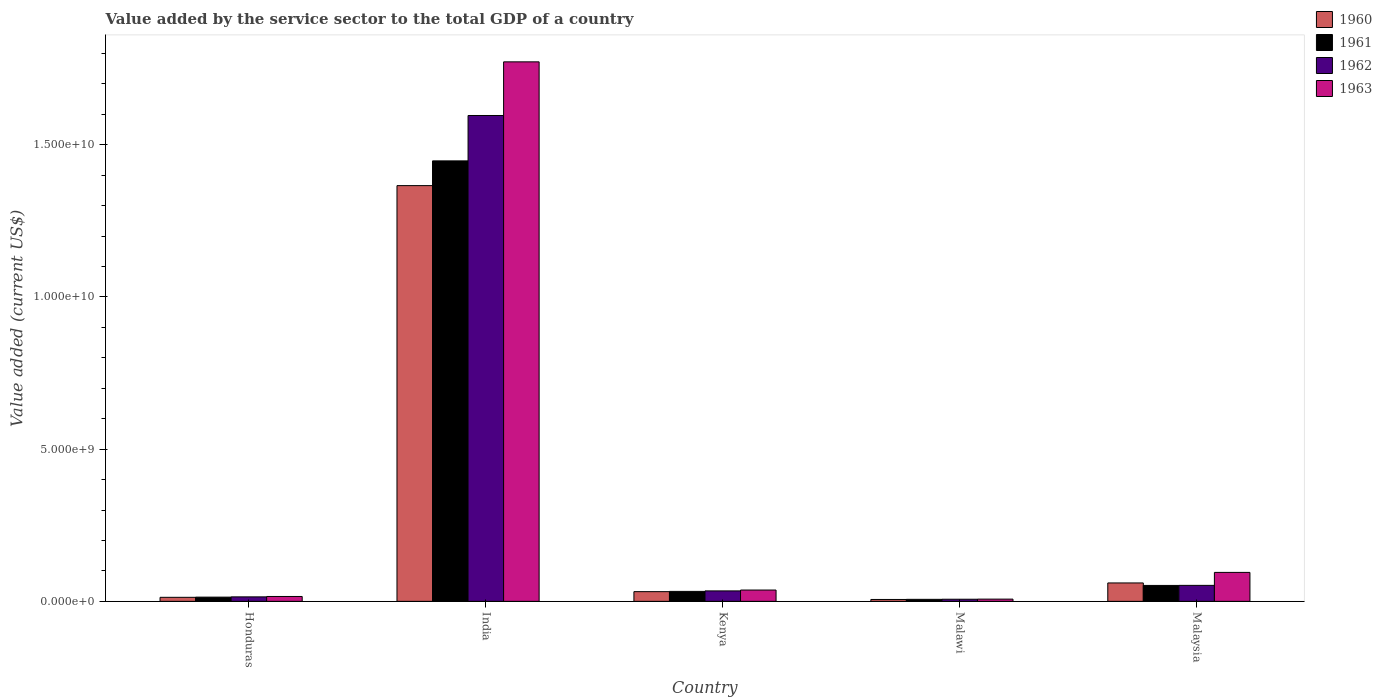Are the number of bars per tick equal to the number of legend labels?
Provide a short and direct response. Yes. Are the number of bars on each tick of the X-axis equal?
Give a very brief answer. Yes. How many bars are there on the 1st tick from the left?
Make the answer very short. 4. How many bars are there on the 2nd tick from the right?
Provide a short and direct response. 4. What is the label of the 5th group of bars from the left?
Give a very brief answer. Malaysia. In how many cases, is the number of bars for a given country not equal to the number of legend labels?
Ensure brevity in your answer.  0. What is the value added by the service sector to the total GDP in 1963 in Honduras?
Provide a short and direct response. 1.60e+08. Across all countries, what is the maximum value added by the service sector to the total GDP in 1962?
Provide a short and direct response. 1.60e+1. Across all countries, what is the minimum value added by the service sector to the total GDP in 1963?
Provide a succinct answer. 7.35e+07. In which country was the value added by the service sector to the total GDP in 1960 minimum?
Your response must be concise. Malawi. What is the total value added by the service sector to the total GDP in 1960 in the graph?
Your answer should be compact. 1.48e+1. What is the difference between the value added by the service sector to the total GDP in 1962 in Malawi and that in Malaysia?
Keep it short and to the point. -4.55e+08. What is the difference between the value added by the service sector to the total GDP in 1963 in Honduras and the value added by the service sector to the total GDP in 1961 in Kenya?
Your response must be concise. -1.67e+08. What is the average value added by the service sector to the total GDP in 1961 per country?
Provide a succinct answer. 3.10e+09. What is the difference between the value added by the service sector to the total GDP of/in 1962 and value added by the service sector to the total GDP of/in 1963 in Honduras?
Your answer should be compact. -1.28e+07. In how many countries, is the value added by the service sector to the total GDP in 1962 greater than 4000000000 US$?
Your response must be concise. 1. What is the ratio of the value added by the service sector to the total GDP in 1962 in India to that in Malaysia?
Ensure brevity in your answer.  30.38. Is the value added by the service sector to the total GDP in 1960 in Honduras less than that in Kenya?
Provide a succinct answer. Yes. Is the difference between the value added by the service sector to the total GDP in 1962 in Honduras and India greater than the difference between the value added by the service sector to the total GDP in 1963 in Honduras and India?
Your answer should be compact. Yes. What is the difference between the highest and the second highest value added by the service sector to the total GDP in 1961?
Make the answer very short. 1.39e+1. What is the difference between the highest and the lowest value added by the service sector to the total GDP in 1961?
Offer a very short reply. 1.44e+1. In how many countries, is the value added by the service sector to the total GDP in 1961 greater than the average value added by the service sector to the total GDP in 1961 taken over all countries?
Keep it short and to the point. 1. What does the 4th bar from the left in Malaysia represents?
Provide a short and direct response. 1963. Is it the case that in every country, the sum of the value added by the service sector to the total GDP in 1962 and value added by the service sector to the total GDP in 1963 is greater than the value added by the service sector to the total GDP in 1960?
Give a very brief answer. Yes. How many bars are there?
Offer a terse response. 20. Are all the bars in the graph horizontal?
Make the answer very short. No. What is the difference between two consecutive major ticks on the Y-axis?
Your answer should be very brief. 5.00e+09. Are the values on the major ticks of Y-axis written in scientific E-notation?
Your answer should be compact. Yes. Does the graph contain any zero values?
Your answer should be very brief. No. Does the graph contain grids?
Your answer should be compact. No. How are the legend labels stacked?
Offer a terse response. Vertical. What is the title of the graph?
Provide a short and direct response. Value added by the service sector to the total GDP of a country. What is the label or title of the Y-axis?
Keep it short and to the point. Value added (current US$). What is the Value added (current US$) in 1960 in Honduras?
Your answer should be very brief. 1.33e+08. What is the Value added (current US$) in 1961 in Honduras?
Offer a very short reply. 1.39e+08. What is the Value added (current US$) of 1962 in Honduras?
Your answer should be very brief. 1.48e+08. What is the Value added (current US$) of 1963 in Honduras?
Provide a short and direct response. 1.60e+08. What is the Value added (current US$) of 1960 in India?
Keep it short and to the point. 1.37e+1. What is the Value added (current US$) of 1961 in India?
Your answer should be compact. 1.45e+1. What is the Value added (current US$) in 1962 in India?
Offer a terse response. 1.60e+1. What is the Value added (current US$) in 1963 in India?
Your answer should be very brief. 1.77e+1. What is the Value added (current US$) of 1960 in Kenya?
Make the answer very short. 3.19e+08. What is the Value added (current US$) of 1961 in Kenya?
Your answer should be very brief. 3.28e+08. What is the Value added (current US$) in 1962 in Kenya?
Offer a very short reply. 3.43e+08. What is the Value added (current US$) in 1963 in Kenya?
Provide a short and direct response. 3.72e+08. What is the Value added (current US$) of 1960 in Malawi?
Provide a succinct answer. 6.24e+07. What is the Value added (current US$) of 1961 in Malawi?
Your answer should be compact. 6.62e+07. What is the Value added (current US$) of 1962 in Malawi?
Make the answer very short. 7.01e+07. What is the Value added (current US$) of 1963 in Malawi?
Make the answer very short. 7.35e+07. What is the Value added (current US$) in 1960 in Malaysia?
Offer a very short reply. 6.05e+08. What is the Value added (current US$) in 1961 in Malaysia?
Your answer should be very brief. 5.23e+08. What is the Value added (current US$) of 1962 in Malaysia?
Keep it short and to the point. 5.25e+08. What is the Value added (current US$) of 1963 in Malaysia?
Make the answer very short. 9.51e+08. Across all countries, what is the maximum Value added (current US$) in 1960?
Offer a terse response. 1.37e+1. Across all countries, what is the maximum Value added (current US$) of 1961?
Offer a very short reply. 1.45e+1. Across all countries, what is the maximum Value added (current US$) of 1962?
Your answer should be compact. 1.60e+1. Across all countries, what is the maximum Value added (current US$) of 1963?
Make the answer very short. 1.77e+1. Across all countries, what is the minimum Value added (current US$) of 1960?
Give a very brief answer. 6.24e+07. Across all countries, what is the minimum Value added (current US$) of 1961?
Make the answer very short. 6.62e+07. Across all countries, what is the minimum Value added (current US$) of 1962?
Ensure brevity in your answer.  7.01e+07. Across all countries, what is the minimum Value added (current US$) in 1963?
Provide a short and direct response. 7.35e+07. What is the total Value added (current US$) in 1960 in the graph?
Offer a very short reply. 1.48e+1. What is the total Value added (current US$) in 1961 in the graph?
Ensure brevity in your answer.  1.55e+1. What is the total Value added (current US$) of 1962 in the graph?
Ensure brevity in your answer.  1.70e+1. What is the total Value added (current US$) of 1963 in the graph?
Offer a terse response. 1.93e+1. What is the difference between the Value added (current US$) in 1960 in Honduras and that in India?
Your response must be concise. -1.35e+1. What is the difference between the Value added (current US$) of 1961 in Honduras and that in India?
Give a very brief answer. -1.43e+1. What is the difference between the Value added (current US$) of 1962 in Honduras and that in India?
Ensure brevity in your answer.  -1.58e+1. What is the difference between the Value added (current US$) in 1963 in Honduras and that in India?
Provide a short and direct response. -1.76e+1. What is the difference between the Value added (current US$) in 1960 in Honduras and that in Kenya?
Offer a very short reply. -1.86e+08. What is the difference between the Value added (current US$) of 1961 in Honduras and that in Kenya?
Provide a succinct answer. -1.89e+08. What is the difference between the Value added (current US$) in 1962 in Honduras and that in Kenya?
Make the answer very short. -1.96e+08. What is the difference between the Value added (current US$) in 1963 in Honduras and that in Kenya?
Give a very brief answer. -2.11e+08. What is the difference between the Value added (current US$) of 1960 in Honduras and that in Malawi?
Provide a succinct answer. 7.02e+07. What is the difference between the Value added (current US$) of 1961 in Honduras and that in Malawi?
Your answer should be compact. 7.25e+07. What is the difference between the Value added (current US$) of 1962 in Honduras and that in Malawi?
Offer a terse response. 7.75e+07. What is the difference between the Value added (current US$) in 1963 in Honduras and that in Malawi?
Ensure brevity in your answer.  8.69e+07. What is the difference between the Value added (current US$) of 1960 in Honduras and that in Malaysia?
Your answer should be very brief. -4.72e+08. What is the difference between the Value added (current US$) in 1961 in Honduras and that in Malaysia?
Make the answer very short. -3.85e+08. What is the difference between the Value added (current US$) in 1962 in Honduras and that in Malaysia?
Give a very brief answer. -3.78e+08. What is the difference between the Value added (current US$) of 1963 in Honduras and that in Malaysia?
Offer a very short reply. -7.91e+08. What is the difference between the Value added (current US$) in 1960 in India and that in Kenya?
Your response must be concise. 1.33e+1. What is the difference between the Value added (current US$) in 1961 in India and that in Kenya?
Offer a terse response. 1.41e+1. What is the difference between the Value added (current US$) of 1962 in India and that in Kenya?
Provide a succinct answer. 1.56e+1. What is the difference between the Value added (current US$) of 1963 in India and that in Kenya?
Ensure brevity in your answer.  1.73e+1. What is the difference between the Value added (current US$) in 1960 in India and that in Malawi?
Offer a very short reply. 1.36e+1. What is the difference between the Value added (current US$) of 1961 in India and that in Malawi?
Offer a very short reply. 1.44e+1. What is the difference between the Value added (current US$) of 1962 in India and that in Malawi?
Your answer should be very brief. 1.59e+1. What is the difference between the Value added (current US$) in 1963 in India and that in Malawi?
Offer a terse response. 1.76e+1. What is the difference between the Value added (current US$) of 1960 in India and that in Malaysia?
Give a very brief answer. 1.31e+1. What is the difference between the Value added (current US$) of 1961 in India and that in Malaysia?
Provide a short and direct response. 1.39e+1. What is the difference between the Value added (current US$) of 1962 in India and that in Malaysia?
Offer a terse response. 1.54e+1. What is the difference between the Value added (current US$) in 1963 in India and that in Malaysia?
Keep it short and to the point. 1.68e+1. What is the difference between the Value added (current US$) in 1960 in Kenya and that in Malawi?
Make the answer very short. 2.57e+08. What is the difference between the Value added (current US$) of 1961 in Kenya and that in Malawi?
Your response must be concise. 2.62e+08. What is the difference between the Value added (current US$) in 1962 in Kenya and that in Malawi?
Provide a short and direct response. 2.73e+08. What is the difference between the Value added (current US$) of 1963 in Kenya and that in Malawi?
Offer a terse response. 2.98e+08. What is the difference between the Value added (current US$) in 1960 in Kenya and that in Malaysia?
Keep it short and to the point. -2.86e+08. What is the difference between the Value added (current US$) in 1961 in Kenya and that in Malaysia?
Your response must be concise. -1.96e+08. What is the difference between the Value added (current US$) in 1962 in Kenya and that in Malaysia?
Keep it short and to the point. -1.82e+08. What is the difference between the Value added (current US$) of 1963 in Kenya and that in Malaysia?
Give a very brief answer. -5.79e+08. What is the difference between the Value added (current US$) in 1960 in Malawi and that in Malaysia?
Provide a short and direct response. -5.43e+08. What is the difference between the Value added (current US$) in 1961 in Malawi and that in Malaysia?
Offer a terse response. -4.57e+08. What is the difference between the Value added (current US$) of 1962 in Malawi and that in Malaysia?
Offer a terse response. -4.55e+08. What is the difference between the Value added (current US$) of 1963 in Malawi and that in Malaysia?
Offer a terse response. -8.78e+08. What is the difference between the Value added (current US$) of 1960 in Honduras and the Value added (current US$) of 1961 in India?
Your answer should be very brief. -1.43e+1. What is the difference between the Value added (current US$) of 1960 in Honduras and the Value added (current US$) of 1962 in India?
Your answer should be compact. -1.58e+1. What is the difference between the Value added (current US$) in 1960 in Honduras and the Value added (current US$) in 1963 in India?
Keep it short and to the point. -1.76e+1. What is the difference between the Value added (current US$) of 1961 in Honduras and the Value added (current US$) of 1962 in India?
Offer a very short reply. -1.58e+1. What is the difference between the Value added (current US$) of 1961 in Honduras and the Value added (current US$) of 1963 in India?
Your response must be concise. -1.76e+1. What is the difference between the Value added (current US$) of 1962 in Honduras and the Value added (current US$) of 1963 in India?
Your answer should be very brief. -1.76e+1. What is the difference between the Value added (current US$) of 1960 in Honduras and the Value added (current US$) of 1961 in Kenya?
Your answer should be compact. -1.95e+08. What is the difference between the Value added (current US$) in 1960 in Honduras and the Value added (current US$) in 1962 in Kenya?
Keep it short and to the point. -2.11e+08. What is the difference between the Value added (current US$) in 1960 in Honduras and the Value added (current US$) in 1963 in Kenya?
Make the answer very short. -2.39e+08. What is the difference between the Value added (current US$) of 1961 in Honduras and the Value added (current US$) of 1962 in Kenya?
Ensure brevity in your answer.  -2.05e+08. What is the difference between the Value added (current US$) of 1961 in Honduras and the Value added (current US$) of 1963 in Kenya?
Your answer should be compact. -2.33e+08. What is the difference between the Value added (current US$) of 1962 in Honduras and the Value added (current US$) of 1963 in Kenya?
Keep it short and to the point. -2.24e+08. What is the difference between the Value added (current US$) in 1960 in Honduras and the Value added (current US$) in 1961 in Malawi?
Your answer should be compact. 6.64e+07. What is the difference between the Value added (current US$) of 1960 in Honduras and the Value added (current US$) of 1962 in Malawi?
Provide a short and direct response. 6.25e+07. What is the difference between the Value added (current US$) of 1960 in Honduras and the Value added (current US$) of 1963 in Malawi?
Make the answer very short. 5.91e+07. What is the difference between the Value added (current US$) in 1961 in Honduras and the Value added (current US$) in 1962 in Malawi?
Offer a very short reply. 6.86e+07. What is the difference between the Value added (current US$) in 1961 in Honduras and the Value added (current US$) in 1963 in Malawi?
Give a very brief answer. 6.52e+07. What is the difference between the Value added (current US$) in 1962 in Honduras and the Value added (current US$) in 1963 in Malawi?
Your answer should be very brief. 7.41e+07. What is the difference between the Value added (current US$) in 1960 in Honduras and the Value added (current US$) in 1961 in Malaysia?
Provide a short and direct response. -3.91e+08. What is the difference between the Value added (current US$) of 1960 in Honduras and the Value added (current US$) of 1962 in Malaysia?
Make the answer very short. -3.93e+08. What is the difference between the Value added (current US$) in 1960 in Honduras and the Value added (current US$) in 1963 in Malaysia?
Provide a succinct answer. -8.18e+08. What is the difference between the Value added (current US$) in 1961 in Honduras and the Value added (current US$) in 1962 in Malaysia?
Give a very brief answer. -3.87e+08. What is the difference between the Value added (current US$) in 1961 in Honduras and the Value added (current US$) in 1963 in Malaysia?
Make the answer very short. -8.12e+08. What is the difference between the Value added (current US$) in 1962 in Honduras and the Value added (current US$) in 1963 in Malaysia?
Your answer should be compact. -8.03e+08. What is the difference between the Value added (current US$) in 1960 in India and the Value added (current US$) in 1961 in Kenya?
Your response must be concise. 1.33e+1. What is the difference between the Value added (current US$) of 1960 in India and the Value added (current US$) of 1962 in Kenya?
Offer a terse response. 1.33e+1. What is the difference between the Value added (current US$) in 1960 in India and the Value added (current US$) in 1963 in Kenya?
Your answer should be compact. 1.33e+1. What is the difference between the Value added (current US$) in 1961 in India and the Value added (current US$) in 1962 in Kenya?
Provide a short and direct response. 1.41e+1. What is the difference between the Value added (current US$) in 1961 in India and the Value added (current US$) in 1963 in Kenya?
Make the answer very short. 1.41e+1. What is the difference between the Value added (current US$) in 1962 in India and the Value added (current US$) in 1963 in Kenya?
Make the answer very short. 1.56e+1. What is the difference between the Value added (current US$) in 1960 in India and the Value added (current US$) in 1961 in Malawi?
Keep it short and to the point. 1.36e+1. What is the difference between the Value added (current US$) of 1960 in India and the Value added (current US$) of 1962 in Malawi?
Your answer should be very brief. 1.36e+1. What is the difference between the Value added (current US$) in 1960 in India and the Value added (current US$) in 1963 in Malawi?
Ensure brevity in your answer.  1.36e+1. What is the difference between the Value added (current US$) in 1961 in India and the Value added (current US$) in 1962 in Malawi?
Provide a short and direct response. 1.44e+1. What is the difference between the Value added (current US$) of 1961 in India and the Value added (current US$) of 1963 in Malawi?
Provide a short and direct response. 1.44e+1. What is the difference between the Value added (current US$) of 1962 in India and the Value added (current US$) of 1963 in Malawi?
Ensure brevity in your answer.  1.59e+1. What is the difference between the Value added (current US$) of 1960 in India and the Value added (current US$) of 1961 in Malaysia?
Give a very brief answer. 1.31e+1. What is the difference between the Value added (current US$) in 1960 in India and the Value added (current US$) in 1962 in Malaysia?
Offer a terse response. 1.31e+1. What is the difference between the Value added (current US$) in 1960 in India and the Value added (current US$) in 1963 in Malaysia?
Provide a short and direct response. 1.27e+1. What is the difference between the Value added (current US$) of 1961 in India and the Value added (current US$) of 1962 in Malaysia?
Keep it short and to the point. 1.39e+1. What is the difference between the Value added (current US$) in 1961 in India and the Value added (current US$) in 1963 in Malaysia?
Your answer should be very brief. 1.35e+1. What is the difference between the Value added (current US$) in 1962 in India and the Value added (current US$) in 1963 in Malaysia?
Make the answer very short. 1.50e+1. What is the difference between the Value added (current US$) of 1960 in Kenya and the Value added (current US$) of 1961 in Malawi?
Provide a short and direct response. 2.53e+08. What is the difference between the Value added (current US$) in 1960 in Kenya and the Value added (current US$) in 1962 in Malawi?
Keep it short and to the point. 2.49e+08. What is the difference between the Value added (current US$) in 1960 in Kenya and the Value added (current US$) in 1963 in Malawi?
Your response must be concise. 2.46e+08. What is the difference between the Value added (current US$) in 1961 in Kenya and the Value added (current US$) in 1962 in Malawi?
Provide a short and direct response. 2.58e+08. What is the difference between the Value added (current US$) of 1961 in Kenya and the Value added (current US$) of 1963 in Malawi?
Offer a very short reply. 2.54e+08. What is the difference between the Value added (current US$) of 1962 in Kenya and the Value added (current US$) of 1963 in Malawi?
Provide a succinct answer. 2.70e+08. What is the difference between the Value added (current US$) of 1960 in Kenya and the Value added (current US$) of 1961 in Malaysia?
Provide a short and direct response. -2.04e+08. What is the difference between the Value added (current US$) in 1960 in Kenya and the Value added (current US$) in 1962 in Malaysia?
Provide a short and direct response. -2.06e+08. What is the difference between the Value added (current US$) in 1960 in Kenya and the Value added (current US$) in 1963 in Malaysia?
Provide a succinct answer. -6.32e+08. What is the difference between the Value added (current US$) in 1961 in Kenya and the Value added (current US$) in 1962 in Malaysia?
Offer a terse response. -1.98e+08. What is the difference between the Value added (current US$) in 1961 in Kenya and the Value added (current US$) in 1963 in Malaysia?
Keep it short and to the point. -6.23e+08. What is the difference between the Value added (current US$) in 1962 in Kenya and the Value added (current US$) in 1963 in Malaysia?
Make the answer very short. -6.08e+08. What is the difference between the Value added (current US$) of 1960 in Malawi and the Value added (current US$) of 1961 in Malaysia?
Make the answer very short. -4.61e+08. What is the difference between the Value added (current US$) in 1960 in Malawi and the Value added (current US$) in 1962 in Malaysia?
Provide a short and direct response. -4.63e+08. What is the difference between the Value added (current US$) of 1960 in Malawi and the Value added (current US$) of 1963 in Malaysia?
Give a very brief answer. -8.89e+08. What is the difference between the Value added (current US$) in 1961 in Malawi and the Value added (current US$) in 1962 in Malaysia?
Offer a terse response. -4.59e+08. What is the difference between the Value added (current US$) of 1961 in Malawi and the Value added (current US$) of 1963 in Malaysia?
Your answer should be compact. -8.85e+08. What is the difference between the Value added (current US$) in 1962 in Malawi and the Value added (current US$) in 1963 in Malaysia?
Your answer should be very brief. -8.81e+08. What is the average Value added (current US$) of 1960 per country?
Make the answer very short. 2.95e+09. What is the average Value added (current US$) of 1961 per country?
Offer a terse response. 3.10e+09. What is the average Value added (current US$) of 1962 per country?
Give a very brief answer. 3.41e+09. What is the average Value added (current US$) of 1963 per country?
Provide a short and direct response. 3.86e+09. What is the difference between the Value added (current US$) of 1960 and Value added (current US$) of 1961 in Honduras?
Provide a succinct answer. -6.15e+06. What is the difference between the Value added (current US$) of 1960 and Value added (current US$) of 1962 in Honduras?
Your response must be concise. -1.50e+07. What is the difference between the Value added (current US$) in 1960 and Value added (current US$) in 1963 in Honduras?
Give a very brief answer. -2.78e+07. What is the difference between the Value added (current US$) of 1961 and Value added (current US$) of 1962 in Honduras?
Your answer should be compact. -8.90e+06. What is the difference between the Value added (current US$) of 1961 and Value added (current US$) of 1963 in Honduras?
Give a very brief answer. -2.17e+07. What is the difference between the Value added (current US$) in 1962 and Value added (current US$) in 1963 in Honduras?
Ensure brevity in your answer.  -1.28e+07. What is the difference between the Value added (current US$) of 1960 and Value added (current US$) of 1961 in India?
Offer a very short reply. -8.13e+08. What is the difference between the Value added (current US$) of 1960 and Value added (current US$) of 1962 in India?
Your response must be concise. -2.30e+09. What is the difference between the Value added (current US$) in 1960 and Value added (current US$) in 1963 in India?
Provide a succinct answer. -4.07e+09. What is the difference between the Value added (current US$) in 1961 and Value added (current US$) in 1962 in India?
Offer a terse response. -1.49e+09. What is the difference between the Value added (current US$) of 1961 and Value added (current US$) of 1963 in India?
Provide a short and direct response. -3.25e+09. What is the difference between the Value added (current US$) of 1962 and Value added (current US$) of 1963 in India?
Give a very brief answer. -1.76e+09. What is the difference between the Value added (current US$) of 1960 and Value added (current US$) of 1961 in Kenya?
Offer a very short reply. -8.81e+06. What is the difference between the Value added (current US$) in 1960 and Value added (current US$) in 1962 in Kenya?
Your response must be concise. -2.43e+07. What is the difference between the Value added (current US$) of 1960 and Value added (current US$) of 1963 in Kenya?
Ensure brevity in your answer.  -5.28e+07. What is the difference between the Value added (current US$) in 1961 and Value added (current US$) in 1962 in Kenya?
Make the answer very short. -1.55e+07. What is the difference between the Value added (current US$) of 1961 and Value added (current US$) of 1963 in Kenya?
Provide a succinct answer. -4.40e+07. What is the difference between the Value added (current US$) in 1962 and Value added (current US$) in 1963 in Kenya?
Provide a succinct answer. -2.84e+07. What is the difference between the Value added (current US$) of 1960 and Value added (current US$) of 1961 in Malawi?
Your answer should be compact. -3.78e+06. What is the difference between the Value added (current US$) in 1960 and Value added (current US$) in 1962 in Malawi?
Keep it short and to the point. -7.70e+06. What is the difference between the Value added (current US$) in 1960 and Value added (current US$) in 1963 in Malawi?
Give a very brief answer. -1.11e+07. What is the difference between the Value added (current US$) of 1961 and Value added (current US$) of 1962 in Malawi?
Your answer should be compact. -3.92e+06. What is the difference between the Value added (current US$) of 1961 and Value added (current US$) of 1963 in Malawi?
Provide a short and direct response. -7.28e+06. What is the difference between the Value added (current US$) in 1962 and Value added (current US$) in 1963 in Malawi?
Your response must be concise. -3.36e+06. What is the difference between the Value added (current US$) in 1960 and Value added (current US$) in 1961 in Malaysia?
Provide a succinct answer. 8.16e+07. What is the difference between the Value added (current US$) in 1960 and Value added (current US$) in 1962 in Malaysia?
Keep it short and to the point. 7.96e+07. What is the difference between the Value added (current US$) of 1960 and Value added (current US$) of 1963 in Malaysia?
Give a very brief answer. -3.46e+08. What is the difference between the Value added (current US$) of 1961 and Value added (current US$) of 1962 in Malaysia?
Give a very brief answer. -2.03e+06. What is the difference between the Value added (current US$) in 1961 and Value added (current US$) in 1963 in Malaysia?
Provide a short and direct response. -4.28e+08. What is the difference between the Value added (current US$) in 1962 and Value added (current US$) in 1963 in Malaysia?
Offer a terse response. -4.26e+08. What is the ratio of the Value added (current US$) of 1960 in Honduras to that in India?
Ensure brevity in your answer.  0.01. What is the ratio of the Value added (current US$) in 1961 in Honduras to that in India?
Your response must be concise. 0.01. What is the ratio of the Value added (current US$) of 1962 in Honduras to that in India?
Your response must be concise. 0.01. What is the ratio of the Value added (current US$) of 1963 in Honduras to that in India?
Offer a very short reply. 0.01. What is the ratio of the Value added (current US$) of 1960 in Honduras to that in Kenya?
Offer a terse response. 0.42. What is the ratio of the Value added (current US$) in 1961 in Honduras to that in Kenya?
Provide a short and direct response. 0.42. What is the ratio of the Value added (current US$) of 1962 in Honduras to that in Kenya?
Offer a very short reply. 0.43. What is the ratio of the Value added (current US$) in 1963 in Honduras to that in Kenya?
Give a very brief answer. 0.43. What is the ratio of the Value added (current US$) in 1960 in Honduras to that in Malawi?
Your answer should be very brief. 2.12. What is the ratio of the Value added (current US$) in 1961 in Honduras to that in Malawi?
Your answer should be very brief. 2.1. What is the ratio of the Value added (current US$) of 1962 in Honduras to that in Malawi?
Your response must be concise. 2.11. What is the ratio of the Value added (current US$) of 1963 in Honduras to that in Malawi?
Your answer should be compact. 2.18. What is the ratio of the Value added (current US$) in 1960 in Honduras to that in Malaysia?
Your response must be concise. 0.22. What is the ratio of the Value added (current US$) of 1961 in Honduras to that in Malaysia?
Provide a short and direct response. 0.27. What is the ratio of the Value added (current US$) of 1962 in Honduras to that in Malaysia?
Your response must be concise. 0.28. What is the ratio of the Value added (current US$) in 1963 in Honduras to that in Malaysia?
Keep it short and to the point. 0.17. What is the ratio of the Value added (current US$) of 1960 in India to that in Kenya?
Make the answer very short. 42.81. What is the ratio of the Value added (current US$) of 1961 in India to that in Kenya?
Your response must be concise. 44.14. What is the ratio of the Value added (current US$) of 1962 in India to that in Kenya?
Your answer should be compact. 46.48. What is the ratio of the Value added (current US$) in 1963 in India to that in Kenya?
Provide a succinct answer. 47.67. What is the ratio of the Value added (current US$) of 1960 in India to that in Malawi?
Provide a short and direct response. 218.7. What is the ratio of the Value added (current US$) of 1961 in India to that in Malawi?
Ensure brevity in your answer.  218.48. What is the ratio of the Value added (current US$) of 1962 in India to that in Malawi?
Provide a succinct answer. 227.53. What is the ratio of the Value added (current US$) of 1963 in India to that in Malawi?
Your response must be concise. 241.1. What is the ratio of the Value added (current US$) in 1960 in India to that in Malaysia?
Provide a short and direct response. 22.57. What is the ratio of the Value added (current US$) in 1961 in India to that in Malaysia?
Give a very brief answer. 27.64. What is the ratio of the Value added (current US$) of 1962 in India to that in Malaysia?
Offer a very short reply. 30.38. What is the ratio of the Value added (current US$) in 1963 in India to that in Malaysia?
Provide a short and direct response. 18.63. What is the ratio of the Value added (current US$) in 1960 in Kenya to that in Malawi?
Provide a short and direct response. 5.11. What is the ratio of the Value added (current US$) of 1961 in Kenya to that in Malawi?
Keep it short and to the point. 4.95. What is the ratio of the Value added (current US$) of 1962 in Kenya to that in Malawi?
Offer a very short reply. 4.89. What is the ratio of the Value added (current US$) of 1963 in Kenya to that in Malawi?
Give a very brief answer. 5.06. What is the ratio of the Value added (current US$) in 1960 in Kenya to that in Malaysia?
Make the answer very short. 0.53. What is the ratio of the Value added (current US$) of 1961 in Kenya to that in Malaysia?
Offer a very short reply. 0.63. What is the ratio of the Value added (current US$) of 1962 in Kenya to that in Malaysia?
Your response must be concise. 0.65. What is the ratio of the Value added (current US$) in 1963 in Kenya to that in Malaysia?
Make the answer very short. 0.39. What is the ratio of the Value added (current US$) in 1960 in Malawi to that in Malaysia?
Give a very brief answer. 0.1. What is the ratio of the Value added (current US$) in 1961 in Malawi to that in Malaysia?
Offer a terse response. 0.13. What is the ratio of the Value added (current US$) of 1962 in Malawi to that in Malaysia?
Ensure brevity in your answer.  0.13. What is the ratio of the Value added (current US$) in 1963 in Malawi to that in Malaysia?
Offer a terse response. 0.08. What is the difference between the highest and the second highest Value added (current US$) in 1960?
Provide a short and direct response. 1.31e+1. What is the difference between the highest and the second highest Value added (current US$) of 1961?
Provide a short and direct response. 1.39e+1. What is the difference between the highest and the second highest Value added (current US$) of 1962?
Keep it short and to the point. 1.54e+1. What is the difference between the highest and the second highest Value added (current US$) in 1963?
Ensure brevity in your answer.  1.68e+1. What is the difference between the highest and the lowest Value added (current US$) in 1960?
Give a very brief answer. 1.36e+1. What is the difference between the highest and the lowest Value added (current US$) in 1961?
Your response must be concise. 1.44e+1. What is the difference between the highest and the lowest Value added (current US$) in 1962?
Make the answer very short. 1.59e+1. What is the difference between the highest and the lowest Value added (current US$) of 1963?
Provide a short and direct response. 1.76e+1. 